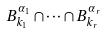<formula> <loc_0><loc_0><loc_500><loc_500>B _ { k _ { 1 } } ^ { \alpha _ { 1 } } \cap \dots \cap B _ { k _ { r } } ^ { \alpha _ { r } }</formula> 